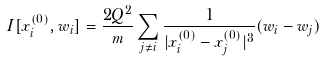Convert formula to latex. <formula><loc_0><loc_0><loc_500><loc_500>I [ x _ { i } ^ { ( 0 ) } , w _ { i } ] = \frac { 2 Q ^ { 2 } } { m } \sum _ { j \neq i } \frac { 1 } { | x _ { i } ^ { ( 0 ) } - x _ { j } ^ { ( 0 ) } | ^ { 3 } } ( w _ { i } - w _ { j } ) \\</formula> 